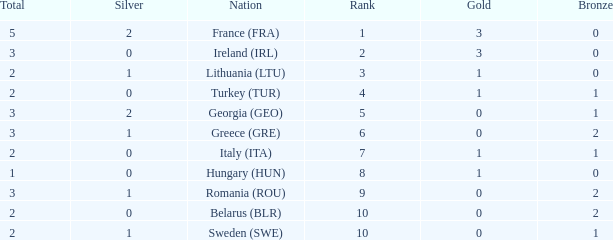Write the full table. {'header': ['Total', 'Silver', 'Nation', 'Rank', 'Gold', 'Bronze'], 'rows': [['5', '2', 'France (FRA)', '1', '3', '0'], ['3', '0', 'Ireland (IRL)', '2', '3', '0'], ['2', '1', 'Lithuania (LTU)', '3', '1', '0'], ['2', '0', 'Turkey (TUR)', '4', '1', '1'], ['3', '2', 'Georgia (GEO)', '5', '0', '1'], ['3', '1', 'Greece (GRE)', '6', '0', '2'], ['2', '0', 'Italy (ITA)', '7', '1', '1'], ['1', '0', 'Hungary (HUN)', '8', '1', '0'], ['3', '1', 'Romania (ROU)', '9', '0', '2'], ['2', '0', 'Belarus (BLR)', '10', '0', '2'], ['2', '1', 'Sweden (SWE)', '10', '0', '1']]} What's the rank of Turkey (TUR) with a total more than 2? 0.0. 